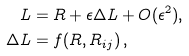Convert formula to latex. <formula><loc_0><loc_0><loc_500><loc_500>L & = R + \epsilon \Delta L + O ( \epsilon ^ { 2 } ) , \\ \Delta L & = f ( R , R _ { i j } ) \, ,</formula> 